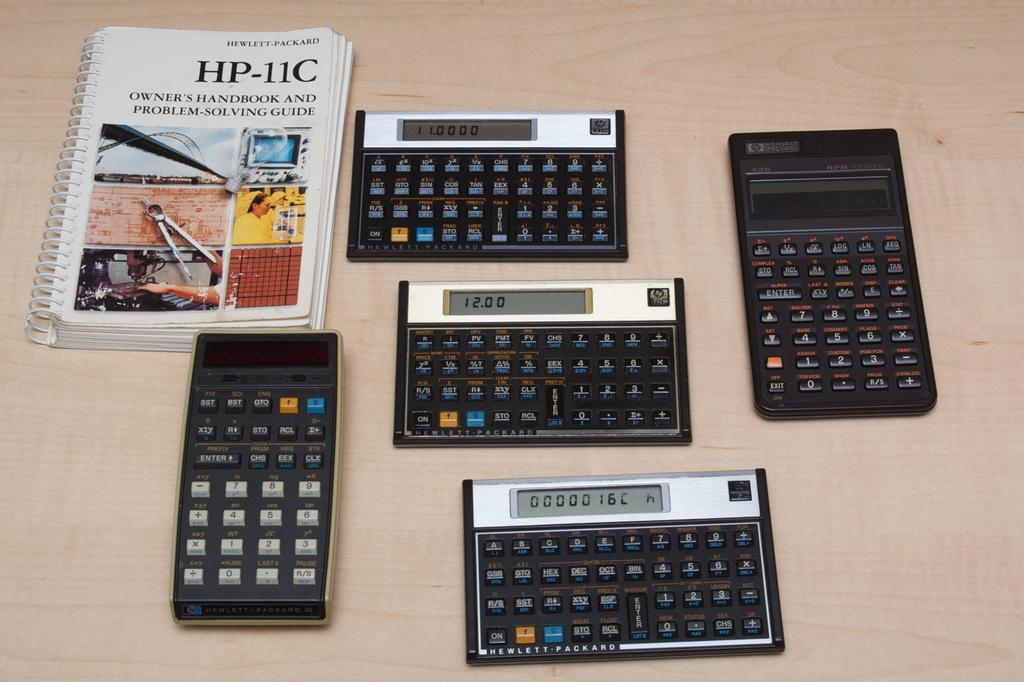<image>
Create a compact narrative representing the image presented. Five Hewlett-Packard calculators are arranged on a table next to an owner's manual and problem-solving guide. 